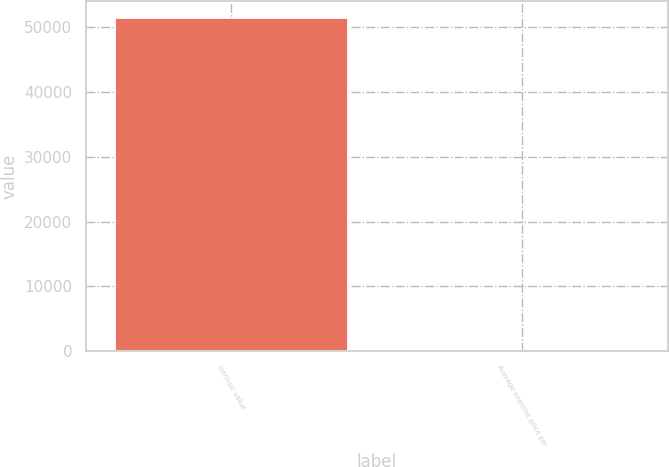Convert chart. <chart><loc_0><loc_0><loc_500><loc_500><bar_chart><fcel>Intrinsic value<fcel>Average exercise price per<nl><fcel>51408<fcel>30.06<nl></chart> 